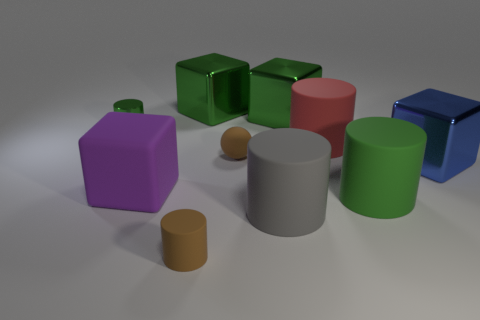Is the rubber ball the same color as the small matte cylinder?
Give a very brief answer. Yes. What size is the brown cylinder that is made of the same material as the big gray cylinder?
Make the answer very short. Small. The large object that is both on the right side of the large red cylinder and behind the large matte cube has what shape?
Your response must be concise. Cube. Is the color of the small sphere in front of the big red cylinder the same as the tiny rubber cylinder?
Provide a short and direct response. Yes. There is a large gray object that is in front of the large purple rubber cube; is it the same shape as the large green thing in front of the green shiny cylinder?
Make the answer very short. Yes. There is a green cylinder behind the large red object; what size is it?
Offer a very short reply. Small. What is the size of the metal cylinder that is behind the metallic block that is in front of the tiny metal cylinder?
Your answer should be very brief. Small. Is the number of green blocks greater than the number of large gray rubber cylinders?
Keep it short and to the point. Yes. Are there more matte cylinders behind the big gray object than gray rubber cylinders in front of the red thing?
Provide a succinct answer. Yes. There is a matte thing that is both left of the gray object and in front of the purple thing; what size is it?
Provide a succinct answer. Small. 